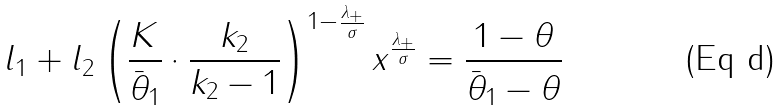Convert formula to latex. <formula><loc_0><loc_0><loc_500><loc_500>l _ { 1 } + l _ { 2 } \left ( \frac { K } { \bar { \theta } _ { 1 } } \cdot \frac { k _ { 2 } } { k _ { 2 } - 1 } \right ) ^ { 1 - \frac { \lambda _ { + } } { \sigma } } x ^ { \frac { \lambda _ { + } } { \sigma } } = \frac { 1 - \theta } { \bar { \theta } _ { 1 } - \theta }</formula> 